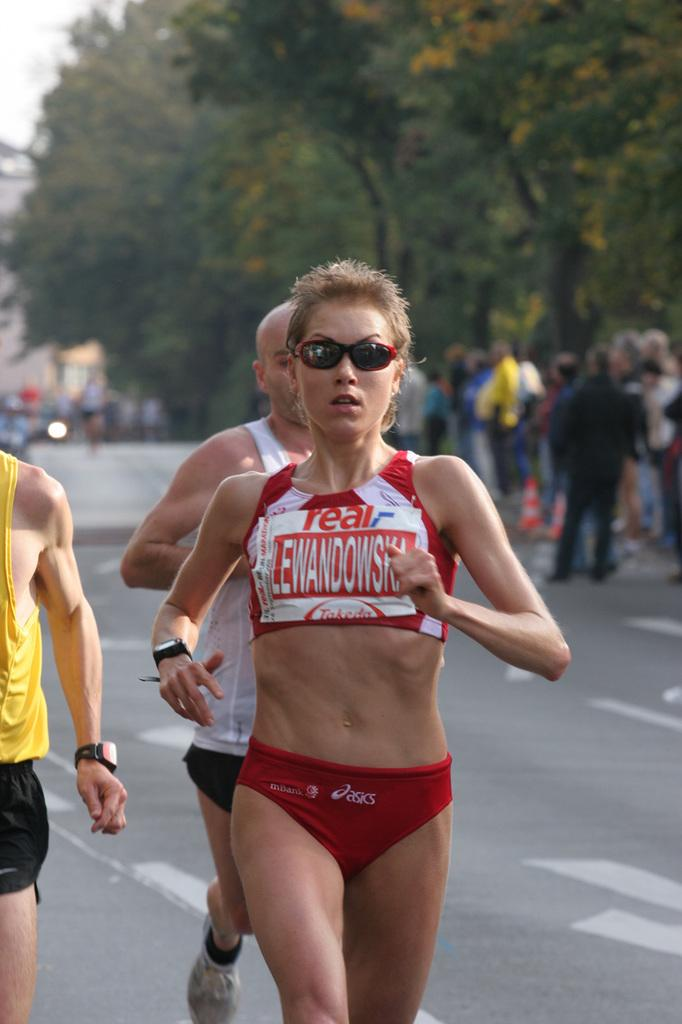<image>
Give a short and clear explanation of the subsequent image. A woman is running in a bikini bottom with the logo asics on it. 